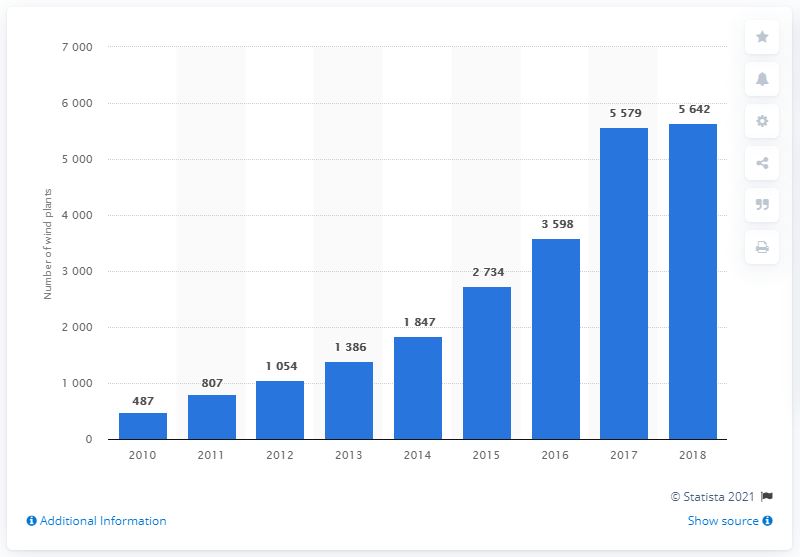Specify some key components in this picture. In 2010, there were 487 wind farms in Italy. 